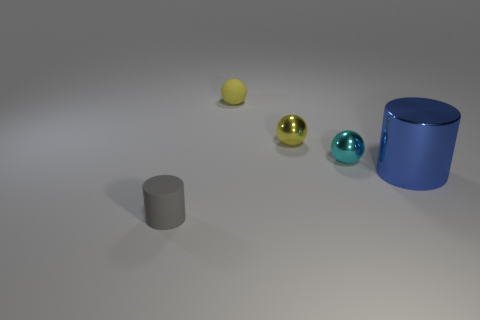Do the rubber cylinder and the tiny metallic sphere that is behind the cyan metal ball have the same color?
Your answer should be very brief. No. There is a cylinder to the right of the rubber thing in front of the rubber object on the right side of the tiny matte cylinder; what color is it?
Make the answer very short. Blue. Are there any other things of the same shape as the yellow metallic thing?
Make the answer very short. Yes. There is a cylinder that is the same size as the cyan object; what color is it?
Provide a short and direct response. Gray. There is a cylinder that is behind the gray rubber object; what is it made of?
Give a very brief answer. Metal. There is a small matte thing that is right of the gray object; is its shape the same as the rubber object in front of the large blue object?
Your response must be concise. No. Are there the same number of small yellow matte balls that are in front of the yellow metallic thing and tiny metallic balls?
Offer a very short reply. No. What number of objects have the same material as the gray cylinder?
Provide a short and direct response. 1. There is a ball that is made of the same material as the tiny gray object; what color is it?
Your answer should be very brief. Yellow. Is the size of the cyan shiny ball the same as the cylinder that is right of the gray matte cylinder?
Make the answer very short. No. 